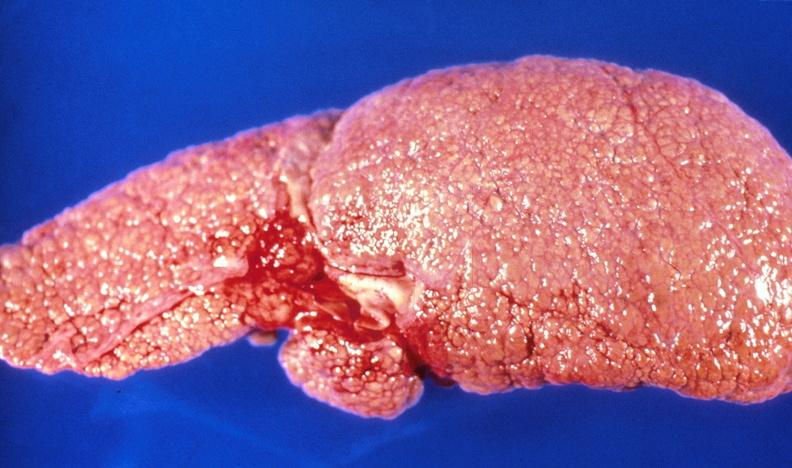does this image show alcoholic cirrhosis?
Answer the question using a single word or phrase. Yes 